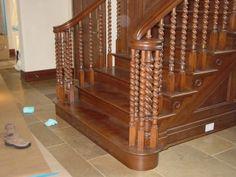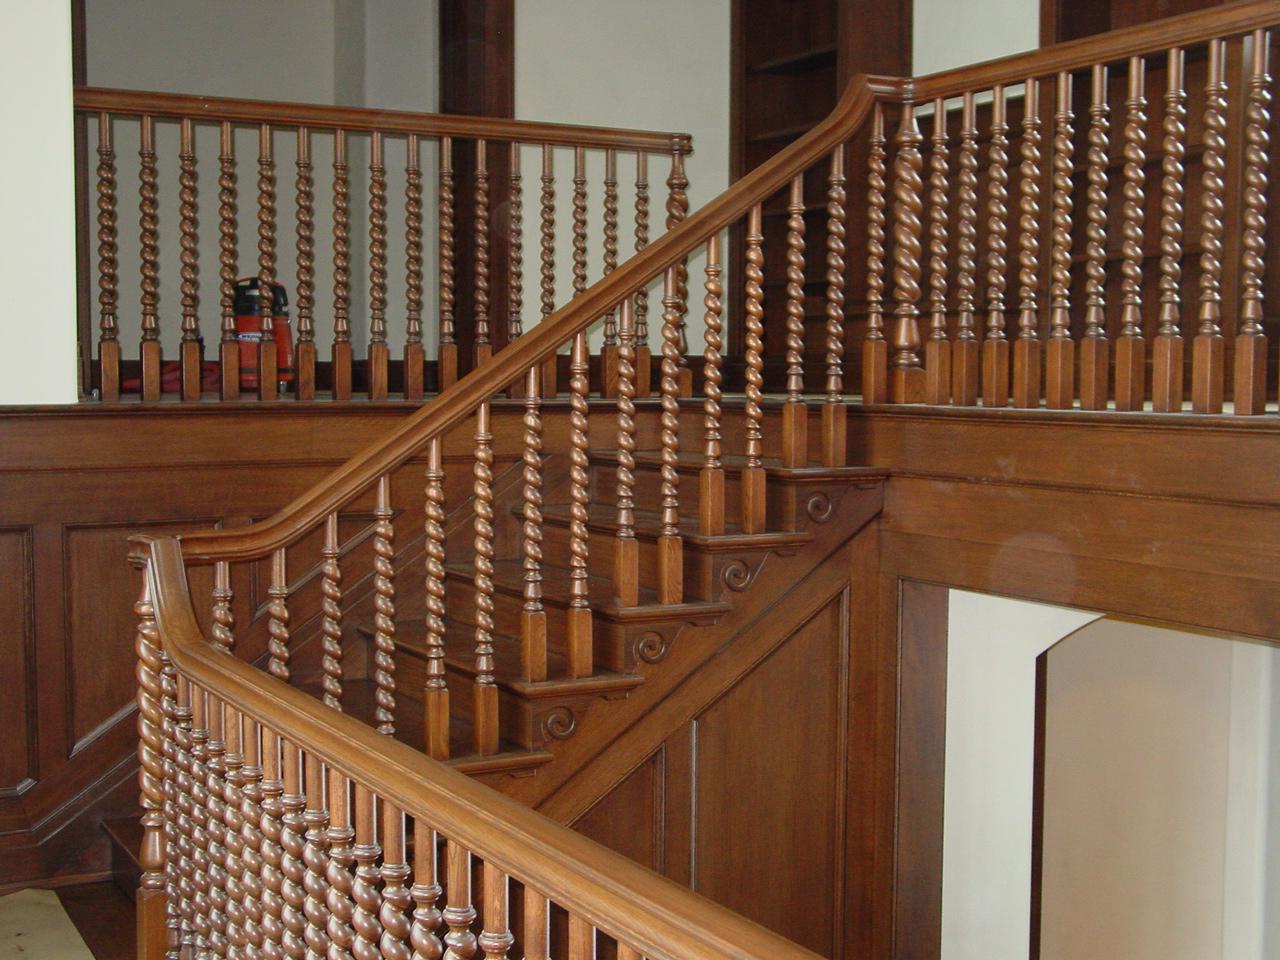The first image is the image on the left, the second image is the image on the right. Evaluate the accuracy of this statement regarding the images: "There are four twisted white pole ment to build a staircase.". Is it true? Answer yes or no. No. The first image is the image on the left, the second image is the image on the right. Considering the images on both sides, is "The left image shows a staircase banister with dark wrought iron bars, and the right image shows a staircase with white spindles on its banister." valid? Answer yes or no. No. 